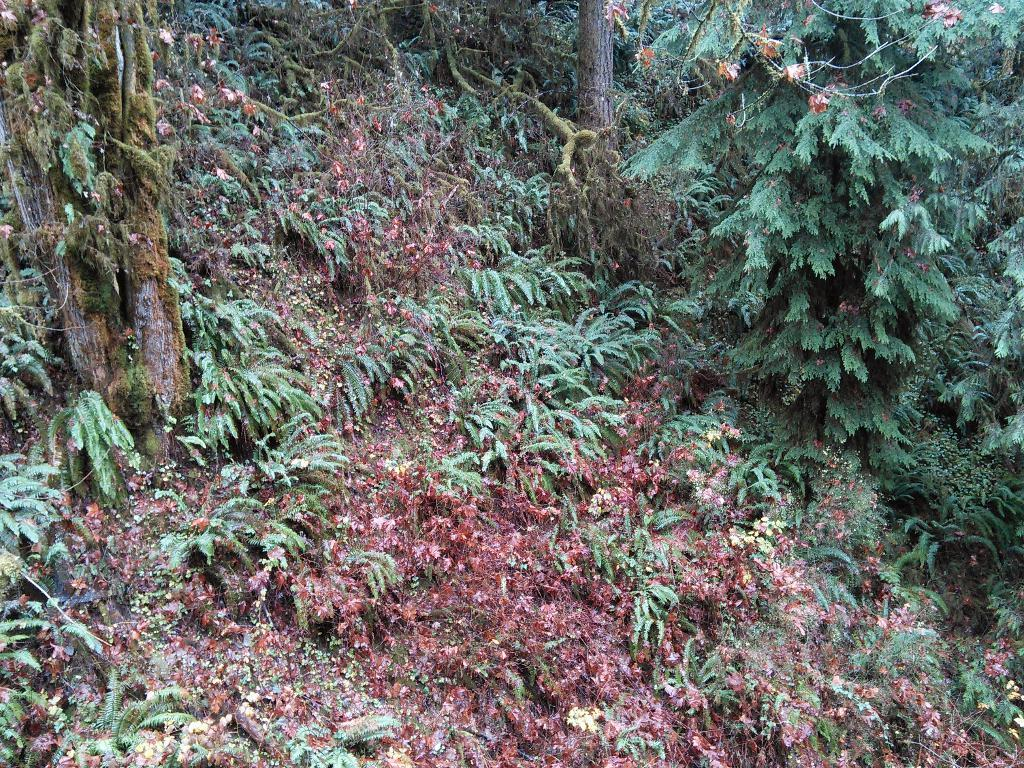What type of environment is depicted in the image? The image appears to be taken in a forest. What can be seen in abundance in the forest? There are many trees in the image. Are there any other types of vegetation besides trees in the image? Yes, there are plants in the image. What is the weight of the nail holding the tree in the image? There is no nail holding a tree in the image; it is a natural forest scene. 